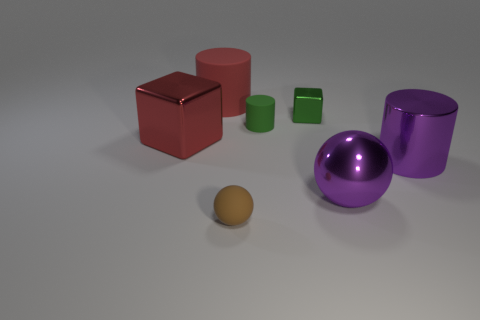Subtract all matte cylinders. How many cylinders are left? 1 Add 2 large blue rubber things. How many objects exist? 9 Subtract all purple balls. How many balls are left? 1 Subtract all balls. How many objects are left? 5 Subtract 3 cylinders. How many cylinders are left? 0 Subtract all green blocks. Subtract all purple cylinders. How many blocks are left? 1 Subtract all tiny green matte things. Subtract all small brown rubber balls. How many objects are left? 5 Add 6 red objects. How many red objects are left? 8 Add 4 small red cylinders. How many small red cylinders exist? 4 Subtract 0 blue cubes. How many objects are left? 7 